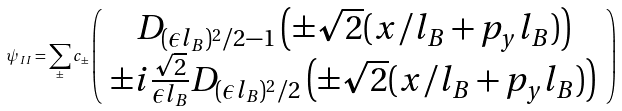<formula> <loc_0><loc_0><loc_500><loc_500>\psi _ { I I } = \sum _ { \pm } c _ { \pm } \left ( \begin{array} { c } D _ { ( \epsilon l _ { B } ) ^ { 2 } / 2 - 1 } \left ( \pm \sqrt { 2 } ( x / l _ { B } + p _ { y } l _ { B } ) \right ) \\ \pm i \frac { \sqrt { 2 } } { \epsilon l _ { B } } D _ { ( \epsilon l _ { B } ) ^ { 2 } / 2 } \left ( \pm \sqrt { 2 } ( x / l _ { B } + p _ { y } l _ { B } ) \right ) \end{array} \right )</formula> 